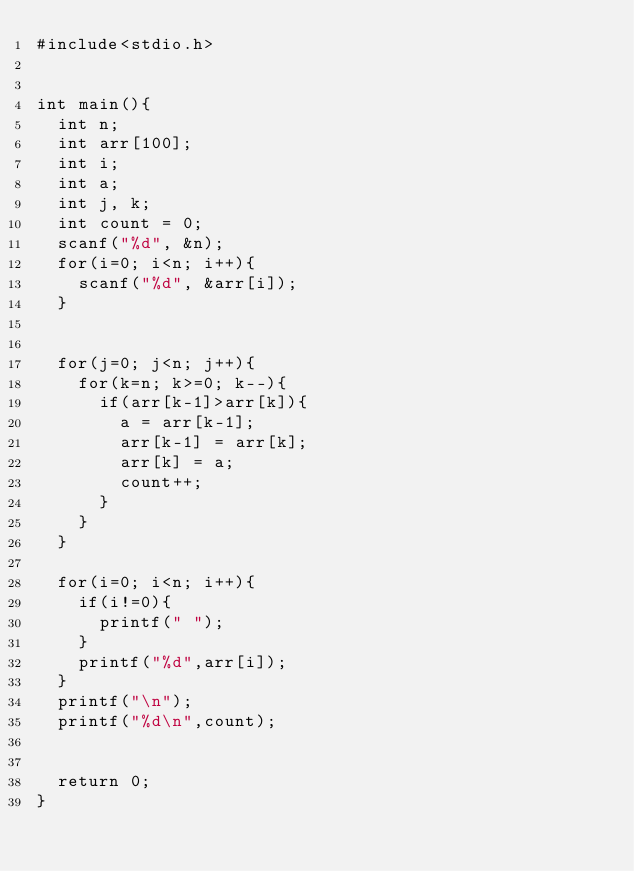Convert code to text. <code><loc_0><loc_0><loc_500><loc_500><_C_>#include<stdio.h>


int main(){
	int n;
	int arr[100];
	int i;
	int a;
	int j, k;
	int count = 0;
	scanf("%d", &n);
	for(i=0; i<n; i++){
		scanf("%d", &arr[i]);
	}
	
	
	for(j=0; j<n; j++){
		for(k=n; k>=0; k--){
			if(arr[k-1]>arr[k]){
				a = arr[k-1];
				arr[k-1] = arr[k];
				arr[k] = a;
				count++;
			}
		}
	}
	
	for(i=0; i<n; i++){
		if(i!=0){
			printf(" ");
		}
		printf("%d",arr[i]);
	}
	printf("\n");
	printf("%d\n",count);
	
	
	return 0;
}</code> 